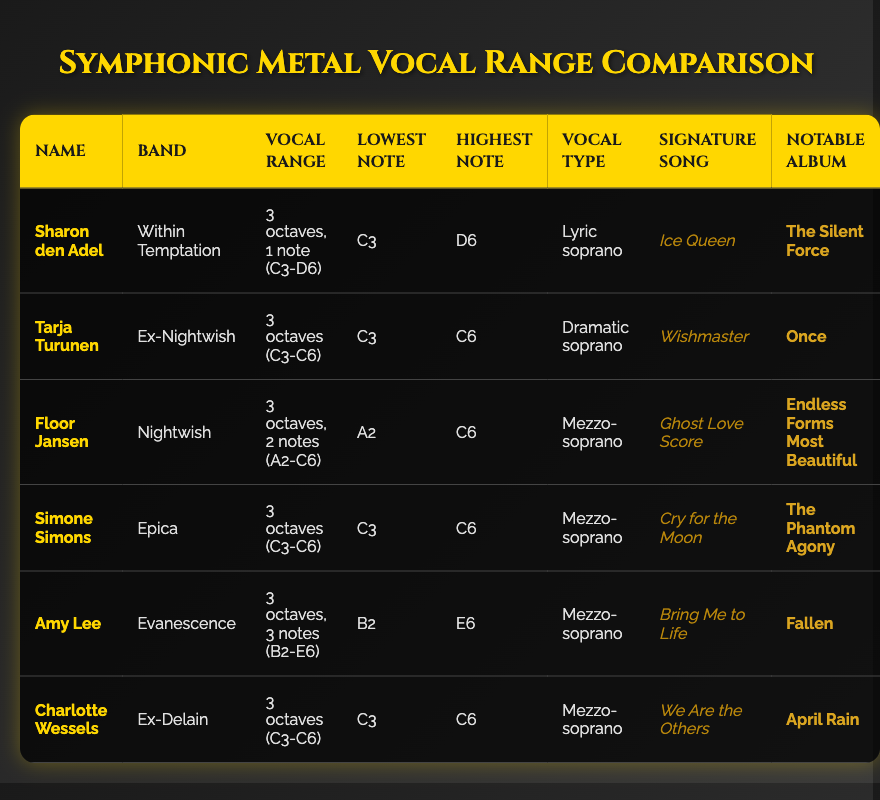What is the vocal range of Sharon den Adel? According to the table, Sharon den Adel has a vocal range of 3 octaves, 1 note, specifically from C3 to D6.
Answer: 3 octaves, 1 note (C3-D6) Which singer has the lowest highest note? The highest notes of the singers are D6 (Sharon den Adel), C6 (Tarja Turunen, Simone Simons, Floor Jansen, Charlotte Wessels), and E6 (Amy Lee). The lowest highest note is C6 shared by multiple singers.
Answer: C6 How many singers have a vocal range of exactly 3 octaves? By reviewing the table, Tarja Turunen, Simone Simons, Charlotte Wessels, and Floor Jansen all have exactly 3 octaves, totaling 4 singers.
Answer: 4 Is Amy Lee a dramatic soprano? The table indicates that Amy Lee is a mezzo-soprano, not a dramatic soprano. Therefore, the statement is false.
Answer: No Which singer has the widest vocal range and what is that range? Amy Lee has the widest vocal range of 3 octaves, 3 notes from B2 to E6, which is greater than the ranges of the other singers in the table.
Answer: 3 octaves, 3 notes (B2-E6) What is the notable album of Tarja Turunen? The notable album for Tarja Turunen as per the table is "Once."
Answer: Once Which vocal type is shared by the most singers in the table? Upon analyzing the table, mezzo-soprano is the vocal type shared by 4 singers: Floor Jansen, Simone Simons, Amy Lee, and Charlotte Wessels.
Answer: Mezzo-soprano Is Sharon den Adel's signature song "Ice Queen"? The table confirms that "Ice Queen" is indeed the signature song of Sharon den Adel.
Answer: Yes What is the highest note of Floor Jansen? According to the table, Floor Jansen's highest note is C6.
Answer: C6 